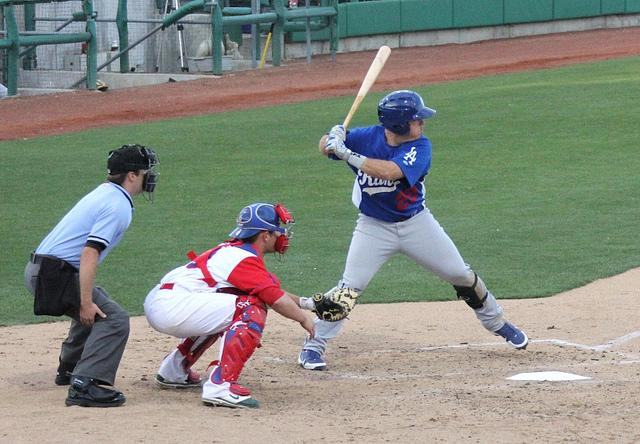What will the next thing the pitcher does? Please explain your reasoning. pitch ball. The pitcher is going to throw the ball. 